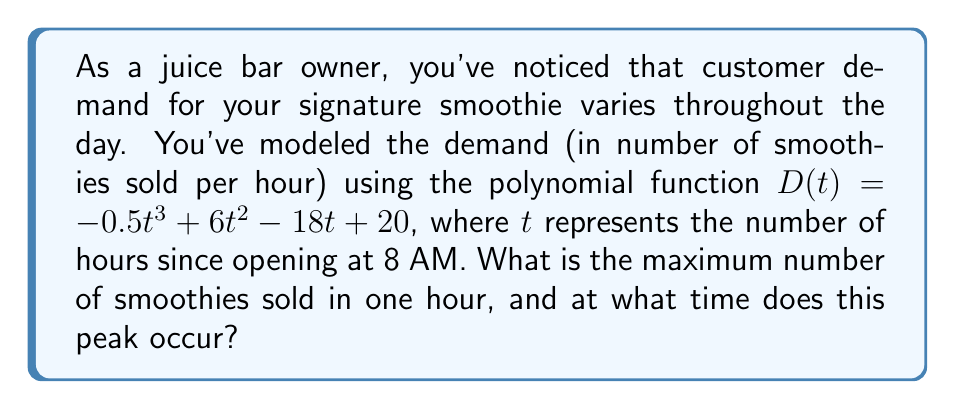Can you solve this math problem? To find the maximum number of smoothies sold and the time it occurs, we need to follow these steps:

1) First, we need to find the derivative of the demand function $D(t)$:
   $$D'(t) = -1.5t^2 + 12t - 18$$

2) To find the critical points, set $D'(t) = 0$ and solve for $t$:
   $$-1.5t^2 + 12t - 18 = 0$$
   $$-1.5(t^2 - 8t + 12) = 0$$
   $$-1.5(t - 2)(t - 6) = 0$$
   $$t = 2 \text{ or } t = 6$$

3) We need to check these critical points and the endpoints of our domain (0 and 12, assuming a 12-hour work day) to determine the maximum:

   At $t = 0$: $D(0) = 20$
   At $t = 2$: $D(2) = -0.5(2)^3 + 6(2)^2 - 18(2) + 20 = -4 + 24 - 36 + 20 = 4$
   At $t = 6$: $D(6) = -0.5(6)^3 + 6(6)^2 - 18(6) + 20 = -108 + 216 - 108 + 20 = 20$
   At $t = 12$: $D(12) = -0.5(12)^3 + 6(12)^2 - 18(12) + 20 = -864 + 864 - 216 + 20 = -196$

4) The maximum value occurs at $t = 6$, which corresponds to 6 hours after opening, or 2 PM.

5) The maximum number of smoothies sold in one hour is $D(6) = 20$.
Answer: 20 smoothies at 2 PM 